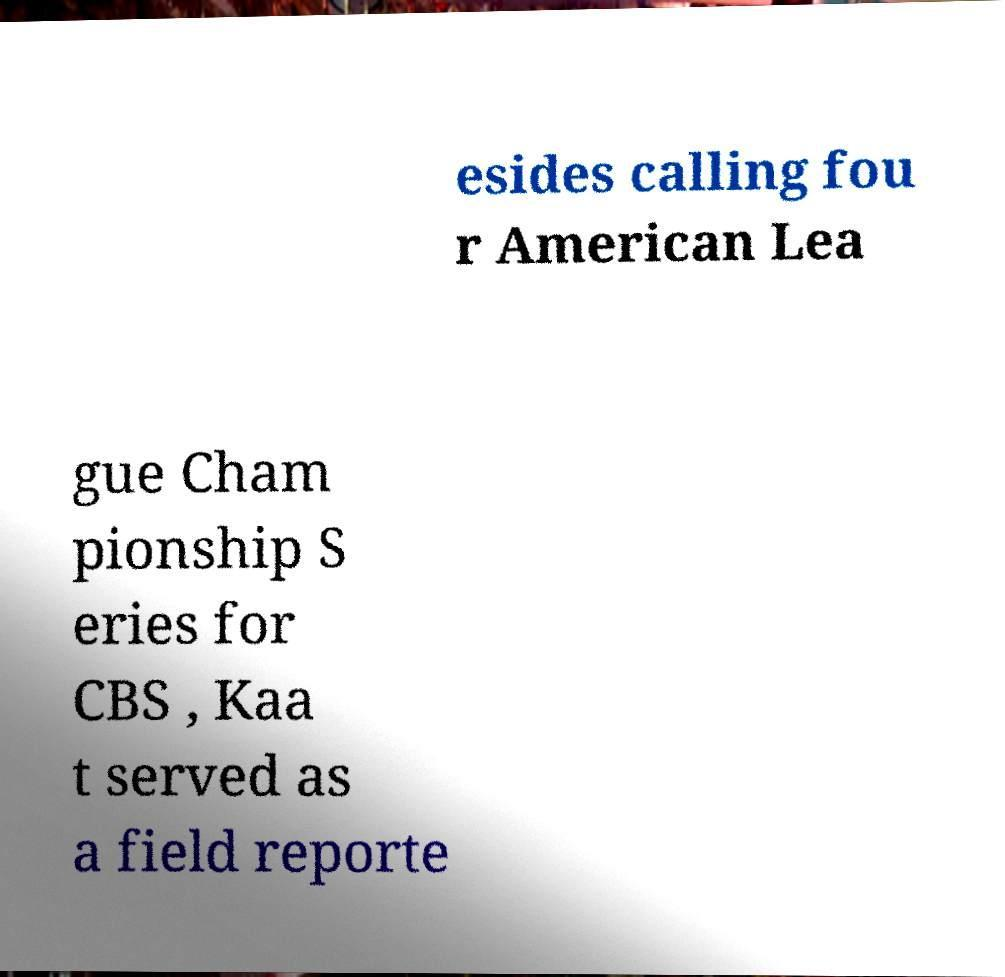Please identify and transcribe the text found in this image. esides calling fou r American Lea gue Cham pionship S eries for CBS , Kaa t served as a field reporte 